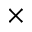Convert formula to latex. <formula><loc_0><loc_0><loc_500><loc_500>\times</formula> 